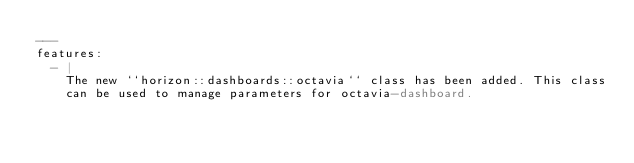<code> <loc_0><loc_0><loc_500><loc_500><_YAML_>---
features:
  - |
    The new ``horizon::dashboards::octavia`` class has been added. This class
    can be used to manage parameters for octavia-dashboard.
</code> 